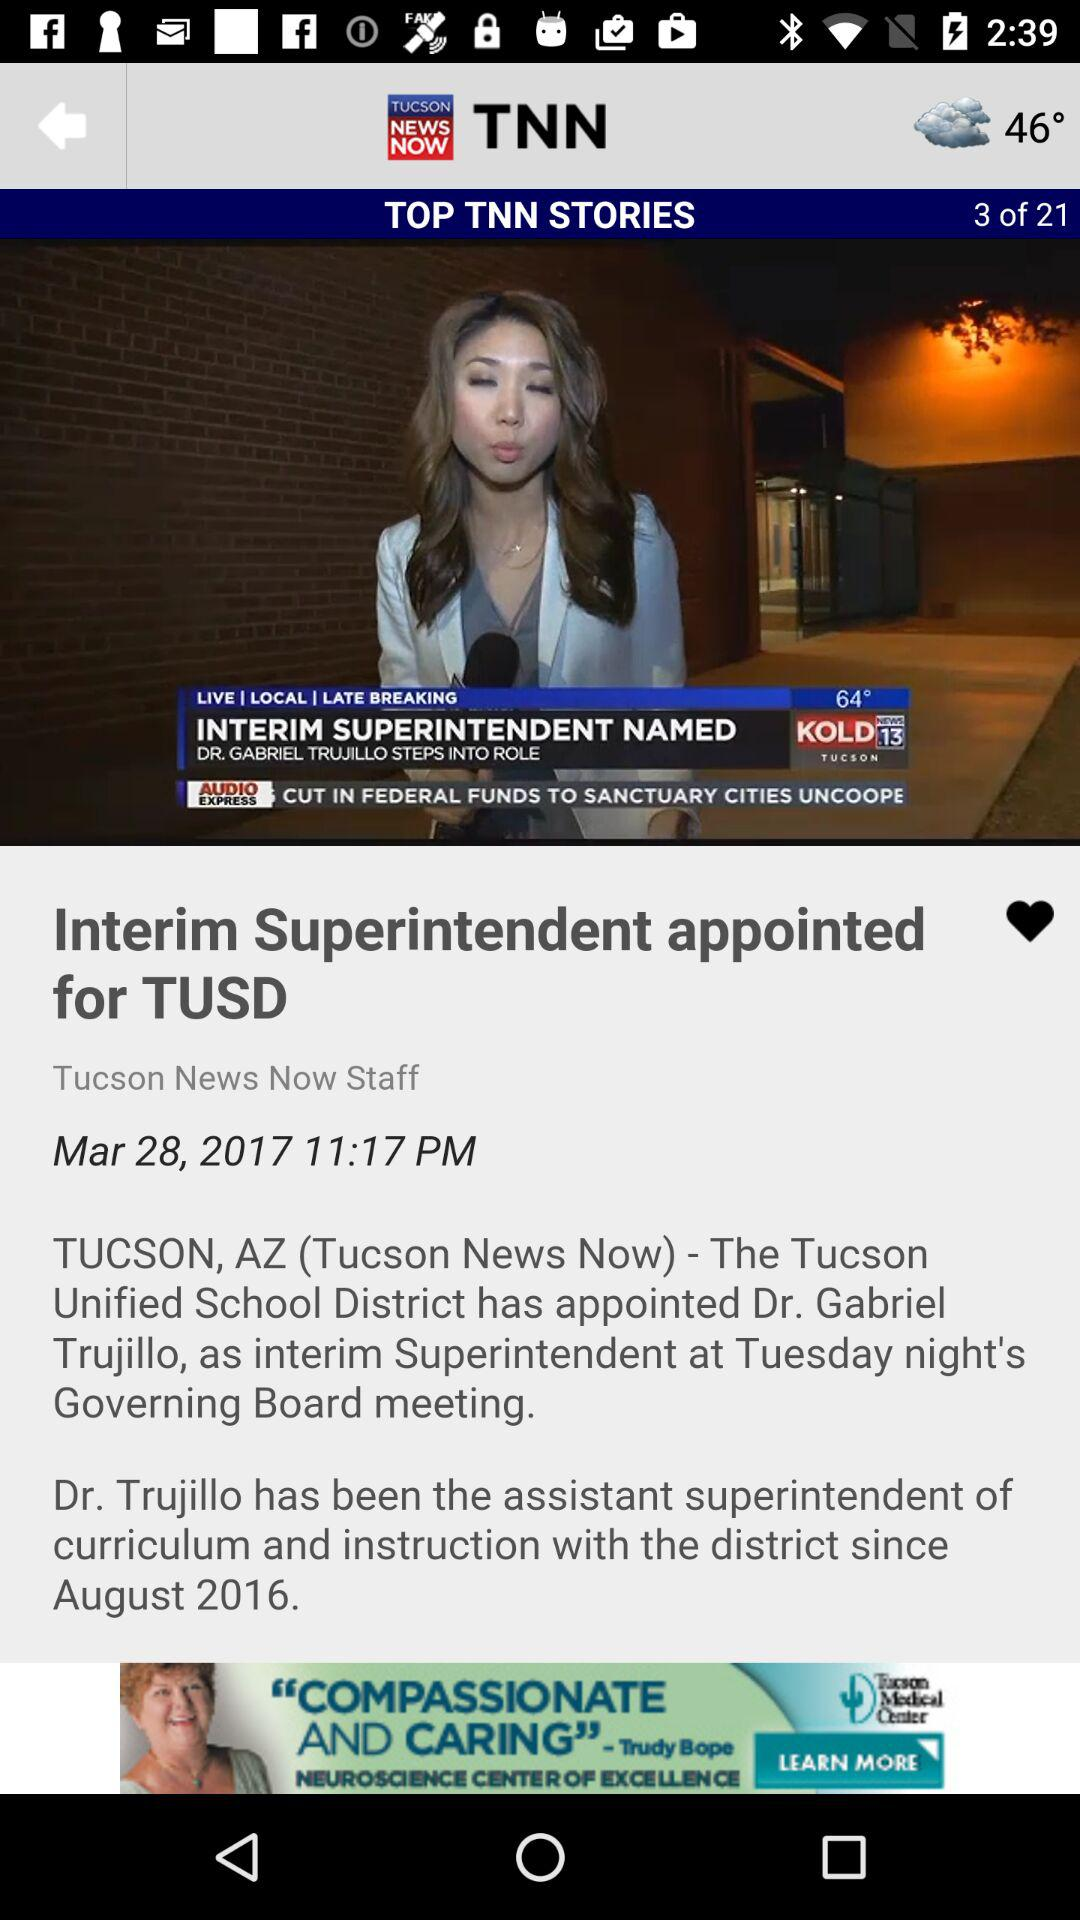What is the total number of stories? The total number of stories is 21. 